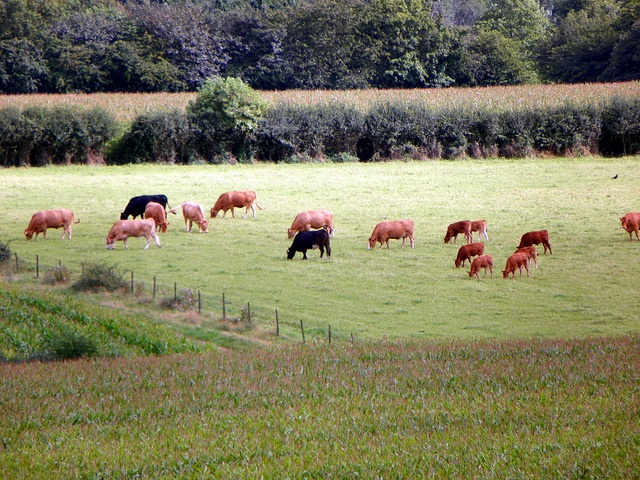Describe the objects in this image and their specific colors. I can see cow in purple, maroon, brown, and tan tones, cow in purple, brown, lightpink, pink, and darkgray tones, cow in purple, maroon, brown, and lightpink tones, cow in purple, brown, lightpink, and maroon tones, and cow in purple, black, gray, navy, and darkgray tones in this image. 